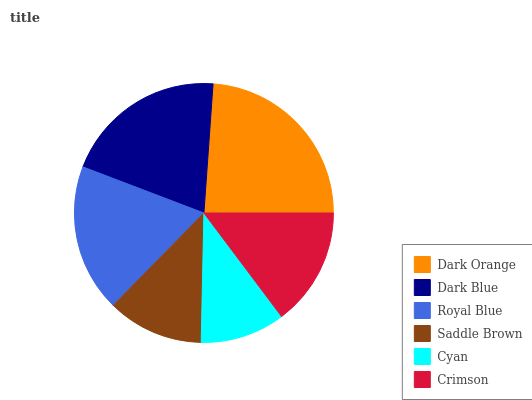Is Cyan the minimum?
Answer yes or no. Yes. Is Dark Orange the maximum?
Answer yes or no. Yes. Is Dark Blue the minimum?
Answer yes or no. No. Is Dark Blue the maximum?
Answer yes or no. No. Is Dark Orange greater than Dark Blue?
Answer yes or no. Yes. Is Dark Blue less than Dark Orange?
Answer yes or no. Yes. Is Dark Blue greater than Dark Orange?
Answer yes or no. No. Is Dark Orange less than Dark Blue?
Answer yes or no. No. Is Royal Blue the high median?
Answer yes or no. Yes. Is Crimson the low median?
Answer yes or no. Yes. Is Crimson the high median?
Answer yes or no. No. Is Dark Blue the low median?
Answer yes or no. No. 